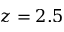<formula> <loc_0><loc_0><loc_500><loc_500>z = 2 . 5</formula> 